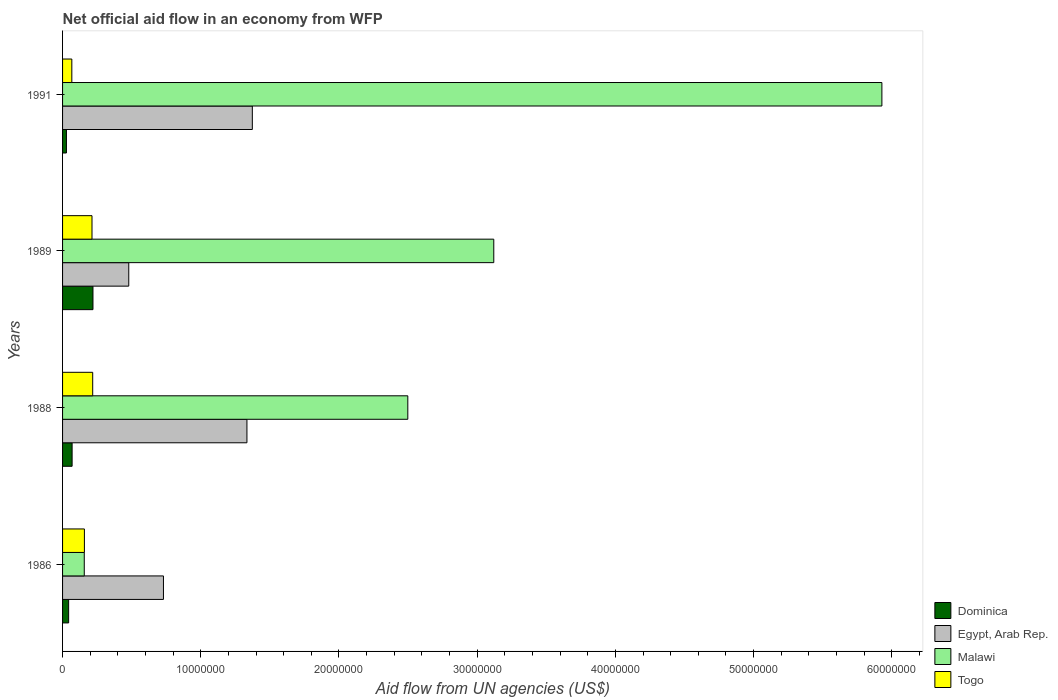Are the number of bars per tick equal to the number of legend labels?
Your response must be concise. Yes. What is the label of the 1st group of bars from the top?
Offer a very short reply. 1991. What is the net official aid flow in Egypt, Arab Rep. in 1991?
Provide a short and direct response. 1.37e+07. Across all years, what is the maximum net official aid flow in Egypt, Arab Rep.?
Provide a short and direct response. 1.37e+07. Across all years, what is the minimum net official aid flow in Togo?
Offer a terse response. 6.70e+05. What is the total net official aid flow in Malawi in the graph?
Keep it short and to the point. 1.17e+08. What is the difference between the net official aid flow in Egypt, Arab Rep. in 1986 and that in 1991?
Provide a short and direct response. -6.43e+06. What is the difference between the net official aid flow in Togo in 1991 and the net official aid flow in Malawi in 1989?
Your response must be concise. -3.05e+07. What is the average net official aid flow in Dominica per year?
Offer a terse response. 9.02e+05. In the year 1989, what is the difference between the net official aid flow in Dominica and net official aid flow in Togo?
Your answer should be very brief. 7.00e+04. What is the ratio of the net official aid flow in Egypt, Arab Rep. in 1989 to that in 1991?
Ensure brevity in your answer.  0.35. What is the difference between the highest and the second highest net official aid flow in Dominica?
Offer a very short reply. 1.51e+06. What is the difference between the highest and the lowest net official aid flow in Dominica?
Offer a terse response. 1.92e+06. Is the sum of the net official aid flow in Dominica in 1988 and 1989 greater than the maximum net official aid flow in Egypt, Arab Rep. across all years?
Provide a succinct answer. No. What does the 1st bar from the top in 1991 represents?
Make the answer very short. Togo. What does the 1st bar from the bottom in 1991 represents?
Your response must be concise. Dominica. Is it the case that in every year, the sum of the net official aid flow in Malawi and net official aid flow in Togo is greater than the net official aid flow in Egypt, Arab Rep.?
Provide a short and direct response. No. Are all the bars in the graph horizontal?
Keep it short and to the point. Yes. What is the difference between two consecutive major ticks on the X-axis?
Give a very brief answer. 1.00e+07. Are the values on the major ticks of X-axis written in scientific E-notation?
Offer a terse response. No. Does the graph contain any zero values?
Your answer should be compact. No. How many legend labels are there?
Make the answer very short. 4. What is the title of the graph?
Provide a succinct answer. Net official aid flow in an economy from WFP. What is the label or title of the X-axis?
Keep it short and to the point. Aid flow from UN agencies (US$). What is the label or title of the Y-axis?
Make the answer very short. Years. What is the Aid flow from UN agencies (US$) of Egypt, Arab Rep. in 1986?
Your answer should be very brief. 7.30e+06. What is the Aid flow from UN agencies (US$) in Malawi in 1986?
Keep it short and to the point. 1.57e+06. What is the Aid flow from UN agencies (US$) in Togo in 1986?
Your answer should be very brief. 1.58e+06. What is the Aid flow from UN agencies (US$) in Dominica in 1988?
Your response must be concise. 6.90e+05. What is the Aid flow from UN agencies (US$) of Egypt, Arab Rep. in 1988?
Provide a succinct answer. 1.33e+07. What is the Aid flow from UN agencies (US$) in Malawi in 1988?
Keep it short and to the point. 2.50e+07. What is the Aid flow from UN agencies (US$) of Togo in 1988?
Provide a short and direct response. 2.18e+06. What is the Aid flow from UN agencies (US$) of Dominica in 1989?
Your response must be concise. 2.20e+06. What is the Aid flow from UN agencies (US$) of Egypt, Arab Rep. in 1989?
Give a very brief answer. 4.79e+06. What is the Aid flow from UN agencies (US$) in Malawi in 1989?
Your answer should be very brief. 3.12e+07. What is the Aid flow from UN agencies (US$) of Togo in 1989?
Offer a very short reply. 2.13e+06. What is the Aid flow from UN agencies (US$) of Dominica in 1991?
Provide a short and direct response. 2.80e+05. What is the Aid flow from UN agencies (US$) in Egypt, Arab Rep. in 1991?
Your response must be concise. 1.37e+07. What is the Aid flow from UN agencies (US$) of Malawi in 1991?
Offer a very short reply. 5.93e+07. What is the Aid flow from UN agencies (US$) of Togo in 1991?
Give a very brief answer. 6.70e+05. Across all years, what is the maximum Aid flow from UN agencies (US$) of Dominica?
Keep it short and to the point. 2.20e+06. Across all years, what is the maximum Aid flow from UN agencies (US$) of Egypt, Arab Rep.?
Ensure brevity in your answer.  1.37e+07. Across all years, what is the maximum Aid flow from UN agencies (US$) of Malawi?
Your response must be concise. 5.93e+07. Across all years, what is the maximum Aid flow from UN agencies (US$) in Togo?
Keep it short and to the point. 2.18e+06. Across all years, what is the minimum Aid flow from UN agencies (US$) of Dominica?
Provide a succinct answer. 2.80e+05. Across all years, what is the minimum Aid flow from UN agencies (US$) of Egypt, Arab Rep.?
Make the answer very short. 4.79e+06. Across all years, what is the minimum Aid flow from UN agencies (US$) of Malawi?
Offer a terse response. 1.57e+06. Across all years, what is the minimum Aid flow from UN agencies (US$) of Togo?
Give a very brief answer. 6.70e+05. What is the total Aid flow from UN agencies (US$) of Dominica in the graph?
Ensure brevity in your answer.  3.61e+06. What is the total Aid flow from UN agencies (US$) of Egypt, Arab Rep. in the graph?
Make the answer very short. 3.92e+07. What is the total Aid flow from UN agencies (US$) of Malawi in the graph?
Your answer should be very brief. 1.17e+08. What is the total Aid flow from UN agencies (US$) of Togo in the graph?
Provide a succinct answer. 6.56e+06. What is the difference between the Aid flow from UN agencies (US$) of Egypt, Arab Rep. in 1986 and that in 1988?
Give a very brief answer. -6.04e+06. What is the difference between the Aid flow from UN agencies (US$) of Malawi in 1986 and that in 1988?
Your answer should be very brief. -2.34e+07. What is the difference between the Aid flow from UN agencies (US$) in Togo in 1986 and that in 1988?
Keep it short and to the point. -6.00e+05. What is the difference between the Aid flow from UN agencies (US$) of Dominica in 1986 and that in 1989?
Offer a terse response. -1.76e+06. What is the difference between the Aid flow from UN agencies (US$) in Egypt, Arab Rep. in 1986 and that in 1989?
Your response must be concise. 2.51e+06. What is the difference between the Aid flow from UN agencies (US$) of Malawi in 1986 and that in 1989?
Ensure brevity in your answer.  -2.96e+07. What is the difference between the Aid flow from UN agencies (US$) of Togo in 1986 and that in 1989?
Offer a very short reply. -5.50e+05. What is the difference between the Aid flow from UN agencies (US$) of Egypt, Arab Rep. in 1986 and that in 1991?
Your answer should be compact. -6.43e+06. What is the difference between the Aid flow from UN agencies (US$) of Malawi in 1986 and that in 1991?
Keep it short and to the point. -5.77e+07. What is the difference between the Aid flow from UN agencies (US$) in Togo in 1986 and that in 1991?
Give a very brief answer. 9.10e+05. What is the difference between the Aid flow from UN agencies (US$) of Dominica in 1988 and that in 1989?
Make the answer very short. -1.51e+06. What is the difference between the Aid flow from UN agencies (US$) in Egypt, Arab Rep. in 1988 and that in 1989?
Offer a very short reply. 8.55e+06. What is the difference between the Aid flow from UN agencies (US$) in Malawi in 1988 and that in 1989?
Give a very brief answer. -6.22e+06. What is the difference between the Aid flow from UN agencies (US$) in Togo in 1988 and that in 1989?
Offer a terse response. 5.00e+04. What is the difference between the Aid flow from UN agencies (US$) in Egypt, Arab Rep. in 1988 and that in 1991?
Your answer should be compact. -3.90e+05. What is the difference between the Aid flow from UN agencies (US$) of Malawi in 1988 and that in 1991?
Your answer should be compact. -3.43e+07. What is the difference between the Aid flow from UN agencies (US$) of Togo in 1988 and that in 1991?
Provide a succinct answer. 1.51e+06. What is the difference between the Aid flow from UN agencies (US$) in Dominica in 1989 and that in 1991?
Keep it short and to the point. 1.92e+06. What is the difference between the Aid flow from UN agencies (US$) of Egypt, Arab Rep. in 1989 and that in 1991?
Provide a succinct answer. -8.94e+06. What is the difference between the Aid flow from UN agencies (US$) of Malawi in 1989 and that in 1991?
Your answer should be compact. -2.81e+07. What is the difference between the Aid flow from UN agencies (US$) of Togo in 1989 and that in 1991?
Offer a very short reply. 1.46e+06. What is the difference between the Aid flow from UN agencies (US$) of Dominica in 1986 and the Aid flow from UN agencies (US$) of Egypt, Arab Rep. in 1988?
Provide a short and direct response. -1.29e+07. What is the difference between the Aid flow from UN agencies (US$) of Dominica in 1986 and the Aid flow from UN agencies (US$) of Malawi in 1988?
Provide a short and direct response. -2.45e+07. What is the difference between the Aid flow from UN agencies (US$) in Dominica in 1986 and the Aid flow from UN agencies (US$) in Togo in 1988?
Offer a very short reply. -1.74e+06. What is the difference between the Aid flow from UN agencies (US$) in Egypt, Arab Rep. in 1986 and the Aid flow from UN agencies (US$) in Malawi in 1988?
Your answer should be compact. -1.77e+07. What is the difference between the Aid flow from UN agencies (US$) in Egypt, Arab Rep. in 1986 and the Aid flow from UN agencies (US$) in Togo in 1988?
Offer a terse response. 5.12e+06. What is the difference between the Aid flow from UN agencies (US$) of Malawi in 1986 and the Aid flow from UN agencies (US$) of Togo in 1988?
Provide a short and direct response. -6.10e+05. What is the difference between the Aid flow from UN agencies (US$) of Dominica in 1986 and the Aid flow from UN agencies (US$) of Egypt, Arab Rep. in 1989?
Keep it short and to the point. -4.35e+06. What is the difference between the Aid flow from UN agencies (US$) of Dominica in 1986 and the Aid flow from UN agencies (US$) of Malawi in 1989?
Provide a succinct answer. -3.08e+07. What is the difference between the Aid flow from UN agencies (US$) in Dominica in 1986 and the Aid flow from UN agencies (US$) in Togo in 1989?
Offer a very short reply. -1.69e+06. What is the difference between the Aid flow from UN agencies (US$) of Egypt, Arab Rep. in 1986 and the Aid flow from UN agencies (US$) of Malawi in 1989?
Give a very brief answer. -2.39e+07. What is the difference between the Aid flow from UN agencies (US$) in Egypt, Arab Rep. in 1986 and the Aid flow from UN agencies (US$) in Togo in 1989?
Provide a short and direct response. 5.17e+06. What is the difference between the Aid flow from UN agencies (US$) of Malawi in 1986 and the Aid flow from UN agencies (US$) of Togo in 1989?
Keep it short and to the point. -5.60e+05. What is the difference between the Aid flow from UN agencies (US$) in Dominica in 1986 and the Aid flow from UN agencies (US$) in Egypt, Arab Rep. in 1991?
Your answer should be very brief. -1.33e+07. What is the difference between the Aid flow from UN agencies (US$) of Dominica in 1986 and the Aid flow from UN agencies (US$) of Malawi in 1991?
Offer a very short reply. -5.88e+07. What is the difference between the Aid flow from UN agencies (US$) in Egypt, Arab Rep. in 1986 and the Aid flow from UN agencies (US$) in Malawi in 1991?
Offer a very short reply. -5.20e+07. What is the difference between the Aid flow from UN agencies (US$) in Egypt, Arab Rep. in 1986 and the Aid flow from UN agencies (US$) in Togo in 1991?
Keep it short and to the point. 6.63e+06. What is the difference between the Aid flow from UN agencies (US$) of Malawi in 1986 and the Aid flow from UN agencies (US$) of Togo in 1991?
Provide a succinct answer. 9.00e+05. What is the difference between the Aid flow from UN agencies (US$) of Dominica in 1988 and the Aid flow from UN agencies (US$) of Egypt, Arab Rep. in 1989?
Keep it short and to the point. -4.10e+06. What is the difference between the Aid flow from UN agencies (US$) of Dominica in 1988 and the Aid flow from UN agencies (US$) of Malawi in 1989?
Give a very brief answer. -3.05e+07. What is the difference between the Aid flow from UN agencies (US$) in Dominica in 1988 and the Aid flow from UN agencies (US$) in Togo in 1989?
Your answer should be very brief. -1.44e+06. What is the difference between the Aid flow from UN agencies (US$) in Egypt, Arab Rep. in 1988 and the Aid flow from UN agencies (US$) in Malawi in 1989?
Provide a short and direct response. -1.79e+07. What is the difference between the Aid flow from UN agencies (US$) in Egypt, Arab Rep. in 1988 and the Aid flow from UN agencies (US$) in Togo in 1989?
Provide a short and direct response. 1.12e+07. What is the difference between the Aid flow from UN agencies (US$) in Malawi in 1988 and the Aid flow from UN agencies (US$) in Togo in 1989?
Your answer should be very brief. 2.28e+07. What is the difference between the Aid flow from UN agencies (US$) of Dominica in 1988 and the Aid flow from UN agencies (US$) of Egypt, Arab Rep. in 1991?
Offer a terse response. -1.30e+07. What is the difference between the Aid flow from UN agencies (US$) in Dominica in 1988 and the Aid flow from UN agencies (US$) in Malawi in 1991?
Provide a short and direct response. -5.86e+07. What is the difference between the Aid flow from UN agencies (US$) in Dominica in 1988 and the Aid flow from UN agencies (US$) in Togo in 1991?
Your answer should be very brief. 2.00e+04. What is the difference between the Aid flow from UN agencies (US$) of Egypt, Arab Rep. in 1988 and the Aid flow from UN agencies (US$) of Malawi in 1991?
Provide a short and direct response. -4.59e+07. What is the difference between the Aid flow from UN agencies (US$) of Egypt, Arab Rep. in 1988 and the Aid flow from UN agencies (US$) of Togo in 1991?
Your response must be concise. 1.27e+07. What is the difference between the Aid flow from UN agencies (US$) in Malawi in 1988 and the Aid flow from UN agencies (US$) in Togo in 1991?
Make the answer very short. 2.43e+07. What is the difference between the Aid flow from UN agencies (US$) of Dominica in 1989 and the Aid flow from UN agencies (US$) of Egypt, Arab Rep. in 1991?
Your answer should be compact. -1.15e+07. What is the difference between the Aid flow from UN agencies (US$) in Dominica in 1989 and the Aid flow from UN agencies (US$) in Malawi in 1991?
Your answer should be very brief. -5.71e+07. What is the difference between the Aid flow from UN agencies (US$) in Dominica in 1989 and the Aid flow from UN agencies (US$) in Togo in 1991?
Make the answer very short. 1.53e+06. What is the difference between the Aid flow from UN agencies (US$) of Egypt, Arab Rep. in 1989 and the Aid flow from UN agencies (US$) of Malawi in 1991?
Your answer should be compact. -5.45e+07. What is the difference between the Aid flow from UN agencies (US$) of Egypt, Arab Rep. in 1989 and the Aid flow from UN agencies (US$) of Togo in 1991?
Make the answer very short. 4.12e+06. What is the difference between the Aid flow from UN agencies (US$) of Malawi in 1989 and the Aid flow from UN agencies (US$) of Togo in 1991?
Ensure brevity in your answer.  3.05e+07. What is the average Aid flow from UN agencies (US$) of Dominica per year?
Offer a very short reply. 9.02e+05. What is the average Aid flow from UN agencies (US$) of Egypt, Arab Rep. per year?
Keep it short and to the point. 9.79e+06. What is the average Aid flow from UN agencies (US$) of Malawi per year?
Make the answer very short. 2.93e+07. What is the average Aid flow from UN agencies (US$) of Togo per year?
Give a very brief answer. 1.64e+06. In the year 1986, what is the difference between the Aid flow from UN agencies (US$) of Dominica and Aid flow from UN agencies (US$) of Egypt, Arab Rep.?
Provide a succinct answer. -6.86e+06. In the year 1986, what is the difference between the Aid flow from UN agencies (US$) of Dominica and Aid flow from UN agencies (US$) of Malawi?
Your answer should be compact. -1.13e+06. In the year 1986, what is the difference between the Aid flow from UN agencies (US$) in Dominica and Aid flow from UN agencies (US$) in Togo?
Ensure brevity in your answer.  -1.14e+06. In the year 1986, what is the difference between the Aid flow from UN agencies (US$) in Egypt, Arab Rep. and Aid flow from UN agencies (US$) in Malawi?
Provide a succinct answer. 5.73e+06. In the year 1986, what is the difference between the Aid flow from UN agencies (US$) of Egypt, Arab Rep. and Aid flow from UN agencies (US$) of Togo?
Make the answer very short. 5.72e+06. In the year 1986, what is the difference between the Aid flow from UN agencies (US$) in Malawi and Aid flow from UN agencies (US$) in Togo?
Give a very brief answer. -10000. In the year 1988, what is the difference between the Aid flow from UN agencies (US$) in Dominica and Aid flow from UN agencies (US$) in Egypt, Arab Rep.?
Your answer should be compact. -1.26e+07. In the year 1988, what is the difference between the Aid flow from UN agencies (US$) in Dominica and Aid flow from UN agencies (US$) in Malawi?
Keep it short and to the point. -2.43e+07. In the year 1988, what is the difference between the Aid flow from UN agencies (US$) in Dominica and Aid flow from UN agencies (US$) in Togo?
Make the answer very short. -1.49e+06. In the year 1988, what is the difference between the Aid flow from UN agencies (US$) of Egypt, Arab Rep. and Aid flow from UN agencies (US$) of Malawi?
Keep it short and to the point. -1.16e+07. In the year 1988, what is the difference between the Aid flow from UN agencies (US$) in Egypt, Arab Rep. and Aid flow from UN agencies (US$) in Togo?
Your response must be concise. 1.12e+07. In the year 1988, what is the difference between the Aid flow from UN agencies (US$) in Malawi and Aid flow from UN agencies (US$) in Togo?
Make the answer very short. 2.28e+07. In the year 1989, what is the difference between the Aid flow from UN agencies (US$) of Dominica and Aid flow from UN agencies (US$) of Egypt, Arab Rep.?
Offer a terse response. -2.59e+06. In the year 1989, what is the difference between the Aid flow from UN agencies (US$) in Dominica and Aid flow from UN agencies (US$) in Malawi?
Your response must be concise. -2.90e+07. In the year 1989, what is the difference between the Aid flow from UN agencies (US$) of Dominica and Aid flow from UN agencies (US$) of Togo?
Provide a succinct answer. 7.00e+04. In the year 1989, what is the difference between the Aid flow from UN agencies (US$) in Egypt, Arab Rep. and Aid flow from UN agencies (US$) in Malawi?
Offer a very short reply. -2.64e+07. In the year 1989, what is the difference between the Aid flow from UN agencies (US$) of Egypt, Arab Rep. and Aid flow from UN agencies (US$) of Togo?
Offer a very short reply. 2.66e+06. In the year 1989, what is the difference between the Aid flow from UN agencies (US$) in Malawi and Aid flow from UN agencies (US$) in Togo?
Your answer should be compact. 2.91e+07. In the year 1991, what is the difference between the Aid flow from UN agencies (US$) of Dominica and Aid flow from UN agencies (US$) of Egypt, Arab Rep.?
Give a very brief answer. -1.34e+07. In the year 1991, what is the difference between the Aid flow from UN agencies (US$) of Dominica and Aid flow from UN agencies (US$) of Malawi?
Offer a terse response. -5.90e+07. In the year 1991, what is the difference between the Aid flow from UN agencies (US$) of Dominica and Aid flow from UN agencies (US$) of Togo?
Your response must be concise. -3.90e+05. In the year 1991, what is the difference between the Aid flow from UN agencies (US$) of Egypt, Arab Rep. and Aid flow from UN agencies (US$) of Malawi?
Offer a terse response. -4.56e+07. In the year 1991, what is the difference between the Aid flow from UN agencies (US$) of Egypt, Arab Rep. and Aid flow from UN agencies (US$) of Togo?
Offer a very short reply. 1.31e+07. In the year 1991, what is the difference between the Aid flow from UN agencies (US$) of Malawi and Aid flow from UN agencies (US$) of Togo?
Make the answer very short. 5.86e+07. What is the ratio of the Aid flow from UN agencies (US$) in Dominica in 1986 to that in 1988?
Your answer should be compact. 0.64. What is the ratio of the Aid flow from UN agencies (US$) of Egypt, Arab Rep. in 1986 to that in 1988?
Make the answer very short. 0.55. What is the ratio of the Aid flow from UN agencies (US$) in Malawi in 1986 to that in 1988?
Ensure brevity in your answer.  0.06. What is the ratio of the Aid flow from UN agencies (US$) of Togo in 1986 to that in 1988?
Offer a terse response. 0.72. What is the ratio of the Aid flow from UN agencies (US$) of Dominica in 1986 to that in 1989?
Your response must be concise. 0.2. What is the ratio of the Aid flow from UN agencies (US$) of Egypt, Arab Rep. in 1986 to that in 1989?
Offer a terse response. 1.52. What is the ratio of the Aid flow from UN agencies (US$) in Malawi in 1986 to that in 1989?
Keep it short and to the point. 0.05. What is the ratio of the Aid flow from UN agencies (US$) of Togo in 1986 to that in 1989?
Keep it short and to the point. 0.74. What is the ratio of the Aid flow from UN agencies (US$) of Dominica in 1986 to that in 1991?
Your response must be concise. 1.57. What is the ratio of the Aid flow from UN agencies (US$) of Egypt, Arab Rep. in 1986 to that in 1991?
Keep it short and to the point. 0.53. What is the ratio of the Aid flow from UN agencies (US$) in Malawi in 1986 to that in 1991?
Ensure brevity in your answer.  0.03. What is the ratio of the Aid flow from UN agencies (US$) of Togo in 1986 to that in 1991?
Give a very brief answer. 2.36. What is the ratio of the Aid flow from UN agencies (US$) of Dominica in 1988 to that in 1989?
Your response must be concise. 0.31. What is the ratio of the Aid flow from UN agencies (US$) in Egypt, Arab Rep. in 1988 to that in 1989?
Provide a succinct answer. 2.79. What is the ratio of the Aid flow from UN agencies (US$) in Malawi in 1988 to that in 1989?
Make the answer very short. 0.8. What is the ratio of the Aid flow from UN agencies (US$) in Togo in 1988 to that in 1989?
Your response must be concise. 1.02. What is the ratio of the Aid flow from UN agencies (US$) of Dominica in 1988 to that in 1991?
Offer a very short reply. 2.46. What is the ratio of the Aid flow from UN agencies (US$) of Egypt, Arab Rep. in 1988 to that in 1991?
Offer a terse response. 0.97. What is the ratio of the Aid flow from UN agencies (US$) in Malawi in 1988 to that in 1991?
Give a very brief answer. 0.42. What is the ratio of the Aid flow from UN agencies (US$) in Togo in 1988 to that in 1991?
Offer a terse response. 3.25. What is the ratio of the Aid flow from UN agencies (US$) of Dominica in 1989 to that in 1991?
Provide a succinct answer. 7.86. What is the ratio of the Aid flow from UN agencies (US$) in Egypt, Arab Rep. in 1989 to that in 1991?
Your response must be concise. 0.35. What is the ratio of the Aid flow from UN agencies (US$) in Malawi in 1989 to that in 1991?
Provide a succinct answer. 0.53. What is the ratio of the Aid flow from UN agencies (US$) in Togo in 1989 to that in 1991?
Ensure brevity in your answer.  3.18. What is the difference between the highest and the second highest Aid flow from UN agencies (US$) in Dominica?
Provide a succinct answer. 1.51e+06. What is the difference between the highest and the second highest Aid flow from UN agencies (US$) of Egypt, Arab Rep.?
Your answer should be compact. 3.90e+05. What is the difference between the highest and the second highest Aid flow from UN agencies (US$) in Malawi?
Provide a short and direct response. 2.81e+07. What is the difference between the highest and the second highest Aid flow from UN agencies (US$) of Togo?
Your answer should be compact. 5.00e+04. What is the difference between the highest and the lowest Aid flow from UN agencies (US$) of Dominica?
Provide a succinct answer. 1.92e+06. What is the difference between the highest and the lowest Aid flow from UN agencies (US$) of Egypt, Arab Rep.?
Provide a short and direct response. 8.94e+06. What is the difference between the highest and the lowest Aid flow from UN agencies (US$) of Malawi?
Offer a terse response. 5.77e+07. What is the difference between the highest and the lowest Aid flow from UN agencies (US$) of Togo?
Make the answer very short. 1.51e+06. 